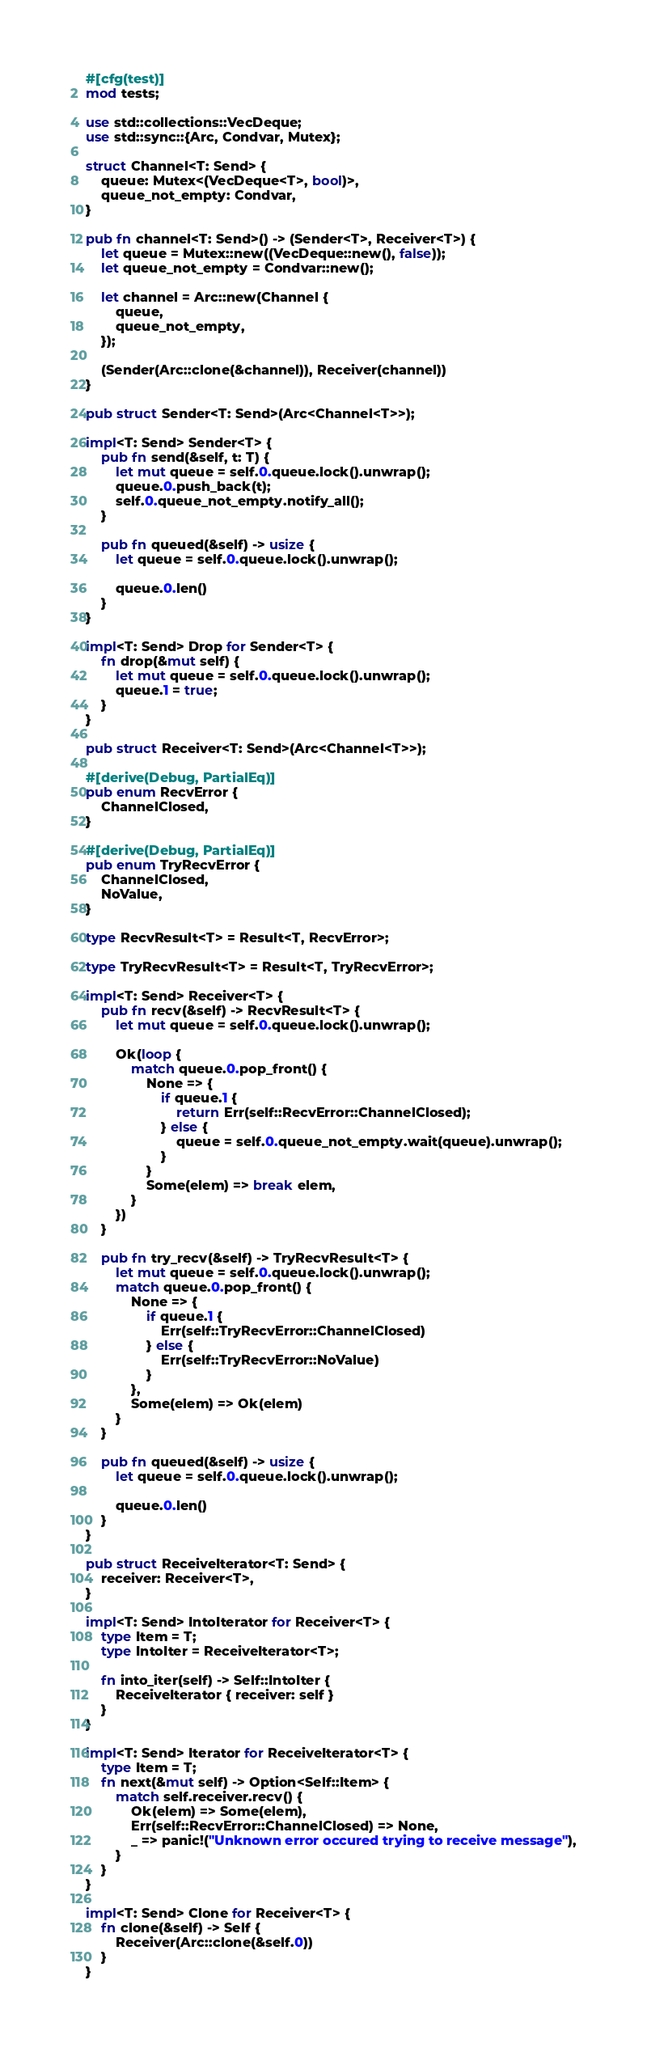<code> <loc_0><loc_0><loc_500><loc_500><_Rust_>#[cfg(test)]
mod tests;

use std::collections::VecDeque;
use std::sync::{Arc, Condvar, Mutex};

struct Channel<T: Send> {
    queue: Mutex<(VecDeque<T>, bool)>,
    queue_not_empty: Condvar,
}

pub fn channel<T: Send>() -> (Sender<T>, Receiver<T>) {
    let queue = Mutex::new((VecDeque::new(), false));
    let queue_not_empty = Condvar::new();

    let channel = Arc::new(Channel {
        queue,
        queue_not_empty,
    });

    (Sender(Arc::clone(&channel)), Receiver(channel))
}

pub struct Sender<T: Send>(Arc<Channel<T>>);

impl<T: Send> Sender<T> {
    pub fn send(&self, t: T) {
        let mut queue = self.0.queue.lock().unwrap();
        queue.0.push_back(t);
        self.0.queue_not_empty.notify_all();
    }

    pub fn queued(&self) -> usize {
        let queue = self.0.queue.lock().unwrap();

        queue.0.len()
    }
}

impl<T: Send> Drop for Sender<T> {
    fn drop(&mut self) {
        let mut queue = self.0.queue.lock().unwrap();
        queue.1 = true;
    }
}

pub struct Receiver<T: Send>(Arc<Channel<T>>);

#[derive(Debug, PartialEq)]
pub enum RecvError {
    ChannelClosed,
}

#[derive(Debug, PartialEq)]
pub enum TryRecvError {
    ChannelClosed,
    NoValue,
}

type RecvResult<T> = Result<T, RecvError>;

type TryRecvResult<T> = Result<T, TryRecvError>;

impl<T: Send> Receiver<T> {
    pub fn recv(&self) -> RecvResult<T> {
        let mut queue = self.0.queue.lock().unwrap();

        Ok(loop {
            match queue.0.pop_front() {
                None => {
                    if queue.1 {
                        return Err(self::RecvError::ChannelClosed);
                    } else {
                        queue = self.0.queue_not_empty.wait(queue).unwrap();
                    }
                }
                Some(elem) => break elem,
            }
        })
    }

    pub fn try_recv(&self) -> TryRecvResult<T> {
        let mut queue = self.0.queue.lock().unwrap();
        match queue.0.pop_front() {
            None => {
                if queue.1 {
                    Err(self::TryRecvError::ChannelClosed)
                } else {
                    Err(self::TryRecvError::NoValue)
                }
            },
            Some(elem) => Ok(elem)
        }
    }

    pub fn queued(&self) -> usize {
        let queue = self.0.queue.lock().unwrap();

        queue.0.len()
    }
}

pub struct ReceiveIterator<T: Send> {
    receiver: Receiver<T>,
}

impl<T: Send> IntoIterator for Receiver<T> {
    type Item = T;
    type IntoIter = ReceiveIterator<T>;

    fn into_iter(self) -> Self::IntoIter {
        ReceiveIterator { receiver: self }
    }
}

impl<T: Send> Iterator for ReceiveIterator<T> {
    type Item = T;
    fn next(&mut self) -> Option<Self::Item> {
        match self.receiver.recv() {
            Ok(elem) => Some(elem),
            Err(self::RecvError::ChannelClosed) => None,
            _ => panic!("Unknown error occured trying to receive message"),
        }
    }
}

impl<T: Send> Clone for Receiver<T> {
    fn clone(&self) -> Self {
        Receiver(Arc::clone(&self.0))
    }
}
</code> 